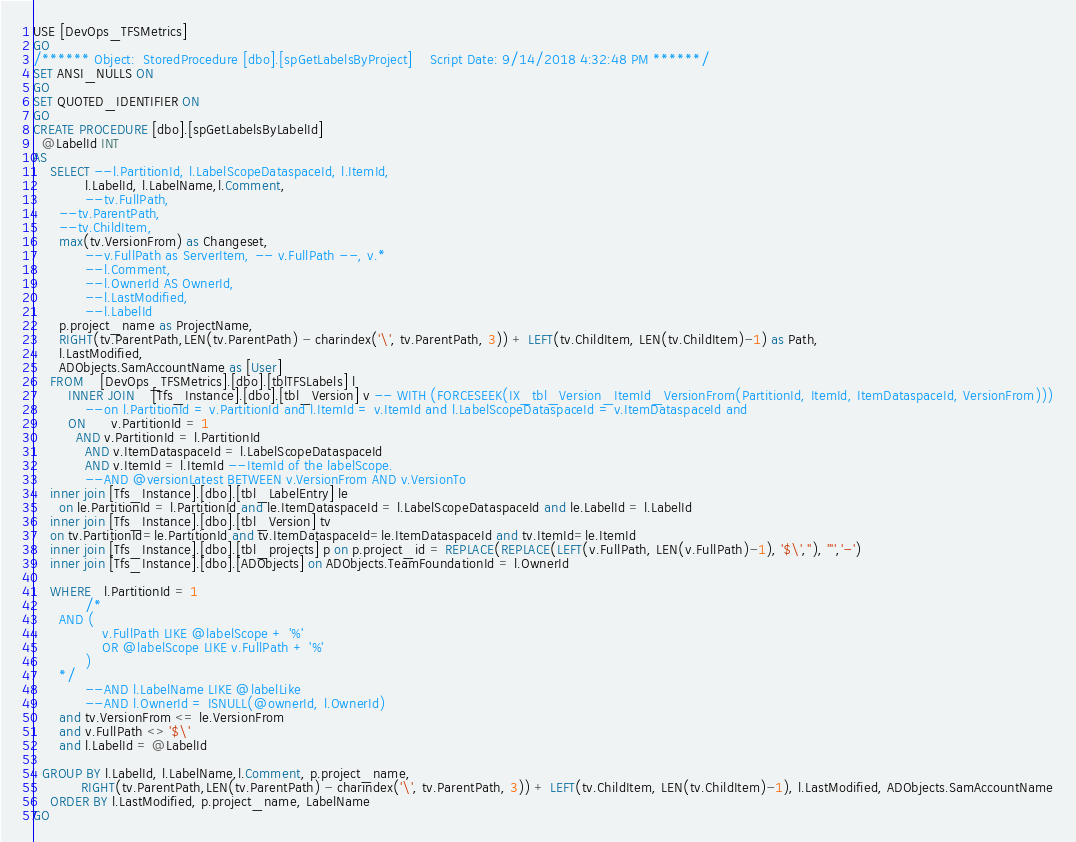Convert code to text. <code><loc_0><loc_0><loc_500><loc_500><_SQL_>USE [DevOps_TFSMetrics]
GO
/****** Object:  StoredProcedure [dbo].[spGetLabelsByProject]    Script Date: 9/14/2018 4:32:48 PM ******/
SET ANSI_NULLS ON
GO
SET QUOTED_IDENTIFIER ON
GO
CREATE PROCEDURE [dbo].[spGetLabelsByLabelId]
  @LabelId INT
AS
    SELECT --l.PartitionId, l.LabelScopeDataspaceId, l.ItemId, 
            l.LabelId, l.LabelName,l.Comment,
            --tv.FullPath, 
      --tv.ParentPath,
      --tv.ChildItem,
      max(tv.VersionFrom) as Changeset,
            --v.FullPath as ServerItem, -- v.FullPath --, v.*
            --l.Comment,
            --l.OwnerId AS OwnerId,
            --l.LastModified,
            --l.LabelId
      p.project_name as ProjectName,
      RIGHT(tv.ParentPath,LEN(tv.ParentPath) - charindex('\', tv.ParentPath, 3)) + LEFT(tv.ChildItem, LEN(tv.ChildItem)-1) as Path,
      l.LastModified,
      ADObjects.SamAccountName as [User]
    FROM    [DevOps_TFSMetrics].[dbo].[tblTFSLabels] l
        INNER JOIN    [Tfs_Instance].[dbo].[tbl_Version] v -- WITH (FORCESEEK(IX_tbl_Version_ItemId_VersionFrom(PartitionId, ItemId, ItemDataspaceId, VersionFrom)))
            --on l.PartitionId = v.PartitionId and l.ItemId = v.ItemId and l.LabelScopeDataspaceId = v.ItemDataspaceId and
        ON      v.PartitionId = 1
          AND v.PartitionId = l.PartitionId
            AND v.ItemDataspaceId = l.LabelScopeDataspaceId
            AND v.ItemId = l.ItemId --ItemId of the labelScope.
            --AND @versionLatest BETWEEN v.VersionFrom AND v.VersionTo
    inner join [Tfs_Instance].[dbo].[tbl_LabelEntry] le
      on le.PartitionId = l.PartitionId and le.ItemDataspaceId = l.LabelScopeDataspaceId and le.LabelId = l.LabelId
    inner join [Tfs_Instance].[dbo].[tbl_Version] tv
    on tv.PartitionId=le.PartitionId and tv.ItemDataspaceId=le.ItemDataspaceId and tv.ItemId=le.ItemId
    inner join [Tfs_Instance].[dbo].[tbl_projects] p on p.project_id = REPLACE(REPLACE(LEFT(v.FullPath, LEN(v.FullPath)-1), '$\',''), '"','-')
    inner join [Tfs_Instance].[dbo].[ADObjects] on ADObjects.TeamFoundationId = l.OwnerId

    WHERE   l.PartitionId = 1
            /*
      AND (
                v.FullPath LIKE @labelScope + '%'
                OR @labelScope LIKE v.FullPath + '%'
            )
      */
            --AND l.LabelName LIKE @labelLike
            --AND l.OwnerId = ISNULL(@ownerId, l.OwnerId)
      and tv.VersionFrom <= le.VersionFrom
      and v.FullPath <> '$\'
      and l.LabelId = @LabelId
    
  GROUP BY l.LabelId, l.LabelName,l.Comment, p.project_name, 
           RIGHT(tv.ParentPath,LEN(tv.ParentPath) - charindex('\', tv.ParentPath, 3)) + LEFT(tv.ChildItem, LEN(tv.ChildItem)-1), l.LastModified, ADObjects.SamAccountName
    ORDER BY l.LastModified, p.project_name, LabelName
GO
</code> 